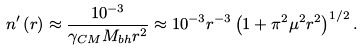Convert formula to latex. <formula><loc_0><loc_0><loc_500><loc_500>n ^ { \prime } \left ( r \right ) \approx \frac { 1 0 ^ { - 3 } } { \gamma _ { C M } M _ { b h } r ^ { 2 } } \approx 1 0 ^ { - 3 } r ^ { - 3 } \left ( 1 + \pi ^ { 2 } \mu ^ { 2 } r ^ { 2 } \right ) ^ { 1 / 2 } .</formula> 